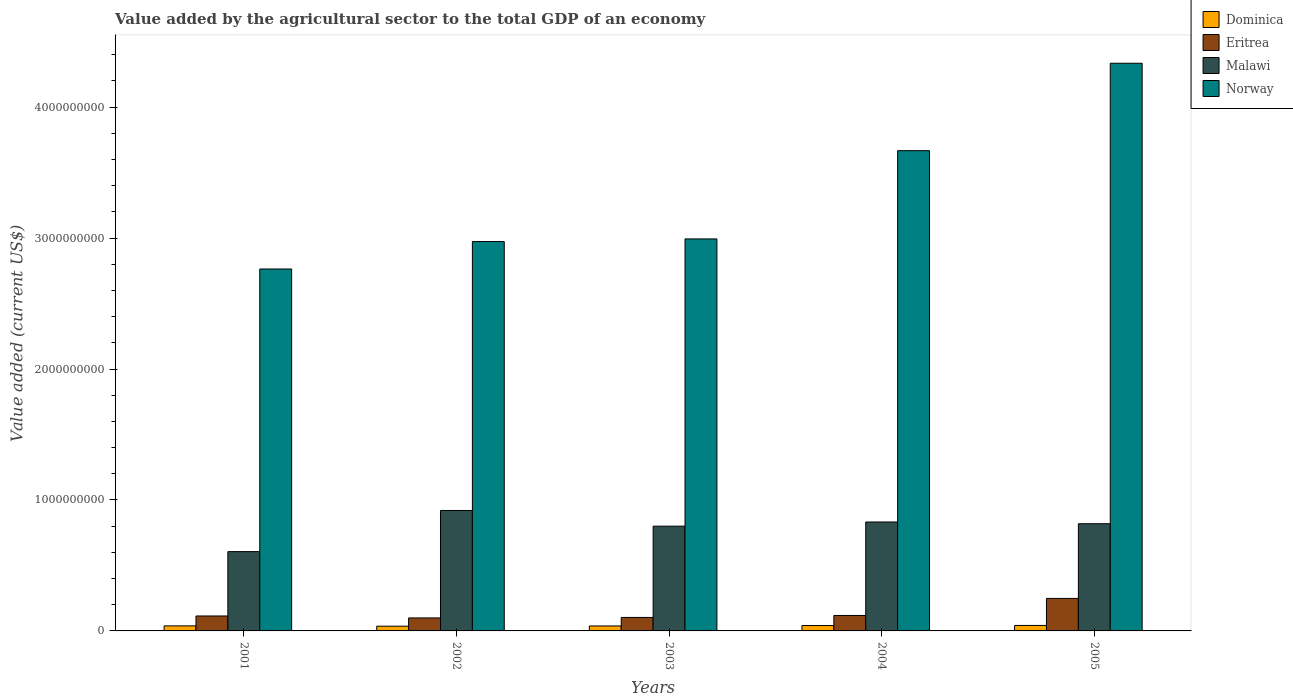How many groups of bars are there?
Provide a succinct answer. 5. Are the number of bars per tick equal to the number of legend labels?
Make the answer very short. Yes. How many bars are there on the 1st tick from the right?
Ensure brevity in your answer.  4. In how many cases, is the number of bars for a given year not equal to the number of legend labels?
Your answer should be compact. 0. What is the value added by the agricultural sector to the total GDP in Malawi in 2001?
Offer a very short reply. 6.06e+08. Across all years, what is the maximum value added by the agricultural sector to the total GDP in Dominica?
Your answer should be very brief. 4.19e+07. Across all years, what is the minimum value added by the agricultural sector to the total GDP in Dominica?
Provide a succinct answer. 3.61e+07. In which year was the value added by the agricultural sector to the total GDP in Eritrea maximum?
Your response must be concise. 2005. What is the total value added by the agricultural sector to the total GDP in Malawi in the graph?
Keep it short and to the point. 3.98e+09. What is the difference between the value added by the agricultural sector to the total GDP in Norway in 2001 and that in 2005?
Offer a very short reply. -1.57e+09. What is the difference between the value added by the agricultural sector to the total GDP in Norway in 2003 and the value added by the agricultural sector to the total GDP in Eritrea in 2004?
Provide a succinct answer. 2.88e+09. What is the average value added by the agricultural sector to the total GDP in Malawi per year?
Your answer should be compact. 7.95e+08. In the year 2005, what is the difference between the value added by the agricultural sector to the total GDP in Dominica and value added by the agricultural sector to the total GDP in Norway?
Offer a terse response. -4.29e+09. What is the ratio of the value added by the agricultural sector to the total GDP in Malawi in 2002 to that in 2005?
Give a very brief answer. 1.12. Is the value added by the agricultural sector to the total GDP in Malawi in 2001 less than that in 2005?
Give a very brief answer. Yes. Is the difference between the value added by the agricultural sector to the total GDP in Dominica in 2002 and 2004 greater than the difference between the value added by the agricultural sector to the total GDP in Norway in 2002 and 2004?
Provide a succinct answer. Yes. What is the difference between the highest and the second highest value added by the agricultural sector to the total GDP in Norway?
Provide a succinct answer. 6.68e+08. What is the difference between the highest and the lowest value added by the agricultural sector to the total GDP in Eritrea?
Ensure brevity in your answer.  1.49e+08. In how many years, is the value added by the agricultural sector to the total GDP in Dominica greater than the average value added by the agricultural sector to the total GDP in Dominica taken over all years?
Provide a short and direct response. 2. Is it the case that in every year, the sum of the value added by the agricultural sector to the total GDP in Dominica and value added by the agricultural sector to the total GDP in Malawi is greater than the sum of value added by the agricultural sector to the total GDP in Eritrea and value added by the agricultural sector to the total GDP in Norway?
Your answer should be very brief. No. What does the 1st bar from the left in 2003 represents?
Ensure brevity in your answer.  Dominica. What does the 3rd bar from the right in 2003 represents?
Ensure brevity in your answer.  Eritrea. Are all the bars in the graph horizontal?
Make the answer very short. No. How many years are there in the graph?
Ensure brevity in your answer.  5. Are the values on the major ticks of Y-axis written in scientific E-notation?
Your answer should be very brief. No. Does the graph contain any zero values?
Give a very brief answer. No. Does the graph contain grids?
Provide a short and direct response. No. How are the legend labels stacked?
Make the answer very short. Vertical. What is the title of the graph?
Your response must be concise. Value added by the agricultural sector to the total GDP of an economy. What is the label or title of the X-axis?
Provide a succinct answer. Years. What is the label or title of the Y-axis?
Make the answer very short. Value added (current US$). What is the Value added (current US$) of Dominica in 2001?
Keep it short and to the point. 3.84e+07. What is the Value added (current US$) in Eritrea in 2001?
Give a very brief answer. 1.14e+08. What is the Value added (current US$) of Malawi in 2001?
Your answer should be very brief. 6.06e+08. What is the Value added (current US$) in Norway in 2001?
Ensure brevity in your answer.  2.76e+09. What is the Value added (current US$) of Dominica in 2002?
Provide a short and direct response. 3.61e+07. What is the Value added (current US$) in Eritrea in 2002?
Offer a very short reply. 9.92e+07. What is the Value added (current US$) of Malawi in 2002?
Give a very brief answer. 9.20e+08. What is the Value added (current US$) of Norway in 2002?
Your answer should be very brief. 2.97e+09. What is the Value added (current US$) in Dominica in 2003?
Make the answer very short. 3.79e+07. What is the Value added (current US$) in Eritrea in 2003?
Give a very brief answer. 1.03e+08. What is the Value added (current US$) in Malawi in 2003?
Ensure brevity in your answer.  8.00e+08. What is the Value added (current US$) of Norway in 2003?
Make the answer very short. 2.99e+09. What is the Value added (current US$) in Dominica in 2004?
Make the answer very short. 4.11e+07. What is the Value added (current US$) of Eritrea in 2004?
Offer a terse response. 1.18e+08. What is the Value added (current US$) in Malawi in 2004?
Give a very brief answer. 8.32e+08. What is the Value added (current US$) in Norway in 2004?
Your answer should be compact. 3.67e+09. What is the Value added (current US$) in Dominica in 2005?
Provide a succinct answer. 4.19e+07. What is the Value added (current US$) in Eritrea in 2005?
Offer a very short reply. 2.48e+08. What is the Value added (current US$) of Malawi in 2005?
Make the answer very short. 8.19e+08. What is the Value added (current US$) in Norway in 2005?
Give a very brief answer. 4.33e+09. Across all years, what is the maximum Value added (current US$) of Dominica?
Your answer should be compact. 4.19e+07. Across all years, what is the maximum Value added (current US$) in Eritrea?
Keep it short and to the point. 2.48e+08. Across all years, what is the maximum Value added (current US$) of Malawi?
Offer a very short reply. 9.20e+08. Across all years, what is the maximum Value added (current US$) of Norway?
Ensure brevity in your answer.  4.33e+09. Across all years, what is the minimum Value added (current US$) of Dominica?
Ensure brevity in your answer.  3.61e+07. Across all years, what is the minimum Value added (current US$) in Eritrea?
Keep it short and to the point. 9.92e+07. Across all years, what is the minimum Value added (current US$) in Malawi?
Offer a very short reply. 6.06e+08. Across all years, what is the minimum Value added (current US$) in Norway?
Ensure brevity in your answer.  2.76e+09. What is the total Value added (current US$) of Dominica in the graph?
Your answer should be compact. 1.95e+08. What is the total Value added (current US$) of Eritrea in the graph?
Your answer should be very brief. 6.83e+08. What is the total Value added (current US$) of Malawi in the graph?
Ensure brevity in your answer.  3.98e+09. What is the total Value added (current US$) of Norway in the graph?
Your answer should be compact. 1.67e+1. What is the difference between the Value added (current US$) of Dominica in 2001 and that in 2002?
Offer a terse response. 2.31e+06. What is the difference between the Value added (current US$) of Eritrea in 2001 and that in 2002?
Give a very brief answer. 1.49e+07. What is the difference between the Value added (current US$) in Malawi in 2001 and that in 2002?
Provide a short and direct response. -3.14e+08. What is the difference between the Value added (current US$) of Norway in 2001 and that in 2002?
Provide a short and direct response. -2.10e+08. What is the difference between the Value added (current US$) of Dominica in 2001 and that in 2003?
Keep it short and to the point. 5.33e+05. What is the difference between the Value added (current US$) in Eritrea in 2001 and that in 2003?
Make the answer very short. 1.11e+07. What is the difference between the Value added (current US$) of Malawi in 2001 and that in 2003?
Your answer should be very brief. -1.94e+08. What is the difference between the Value added (current US$) in Norway in 2001 and that in 2003?
Provide a short and direct response. -2.30e+08. What is the difference between the Value added (current US$) of Dominica in 2001 and that in 2004?
Make the answer very short. -2.69e+06. What is the difference between the Value added (current US$) of Eritrea in 2001 and that in 2004?
Offer a terse response. -3.94e+06. What is the difference between the Value added (current US$) in Malawi in 2001 and that in 2004?
Keep it short and to the point. -2.26e+08. What is the difference between the Value added (current US$) of Norway in 2001 and that in 2004?
Make the answer very short. -9.03e+08. What is the difference between the Value added (current US$) in Dominica in 2001 and that in 2005?
Provide a short and direct response. -3.42e+06. What is the difference between the Value added (current US$) of Eritrea in 2001 and that in 2005?
Offer a terse response. -1.34e+08. What is the difference between the Value added (current US$) in Malawi in 2001 and that in 2005?
Give a very brief answer. -2.13e+08. What is the difference between the Value added (current US$) of Norway in 2001 and that in 2005?
Provide a short and direct response. -1.57e+09. What is the difference between the Value added (current US$) in Dominica in 2002 and that in 2003?
Your answer should be very brief. -1.78e+06. What is the difference between the Value added (current US$) of Eritrea in 2002 and that in 2003?
Your response must be concise. -3.75e+06. What is the difference between the Value added (current US$) in Malawi in 2002 and that in 2003?
Provide a short and direct response. 1.20e+08. What is the difference between the Value added (current US$) of Norway in 2002 and that in 2003?
Keep it short and to the point. -2.02e+07. What is the difference between the Value added (current US$) of Dominica in 2002 and that in 2004?
Provide a succinct answer. -5.00e+06. What is the difference between the Value added (current US$) in Eritrea in 2002 and that in 2004?
Offer a terse response. -1.88e+07. What is the difference between the Value added (current US$) in Malawi in 2002 and that in 2004?
Provide a short and direct response. 8.80e+07. What is the difference between the Value added (current US$) of Norway in 2002 and that in 2004?
Provide a succinct answer. -6.94e+08. What is the difference between the Value added (current US$) of Dominica in 2002 and that in 2005?
Your response must be concise. -5.73e+06. What is the difference between the Value added (current US$) in Eritrea in 2002 and that in 2005?
Your response must be concise. -1.49e+08. What is the difference between the Value added (current US$) of Malawi in 2002 and that in 2005?
Provide a short and direct response. 1.01e+08. What is the difference between the Value added (current US$) of Norway in 2002 and that in 2005?
Make the answer very short. -1.36e+09. What is the difference between the Value added (current US$) of Dominica in 2003 and that in 2004?
Keep it short and to the point. -3.22e+06. What is the difference between the Value added (current US$) in Eritrea in 2003 and that in 2004?
Your answer should be very brief. -1.51e+07. What is the difference between the Value added (current US$) in Malawi in 2003 and that in 2004?
Provide a short and direct response. -3.19e+07. What is the difference between the Value added (current US$) in Norway in 2003 and that in 2004?
Ensure brevity in your answer.  -6.74e+08. What is the difference between the Value added (current US$) in Dominica in 2003 and that in 2005?
Your response must be concise. -3.96e+06. What is the difference between the Value added (current US$) of Eritrea in 2003 and that in 2005?
Your answer should be very brief. -1.45e+08. What is the difference between the Value added (current US$) of Malawi in 2003 and that in 2005?
Your answer should be very brief. -1.87e+07. What is the difference between the Value added (current US$) in Norway in 2003 and that in 2005?
Give a very brief answer. -1.34e+09. What is the difference between the Value added (current US$) in Dominica in 2004 and that in 2005?
Make the answer very short. -7.34e+05. What is the difference between the Value added (current US$) of Eritrea in 2004 and that in 2005?
Offer a terse response. -1.30e+08. What is the difference between the Value added (current US$) in Malawi in 2004 and that in 2005?
Ensure brevity in your answer.  1.32e+07. What is the difference between the Value added (current US$) in Norway in 2004 and that in 2005?
Your answer should be very brief. -6.68e+08. What is the difference between the Value added (current US$) of Dominica in 2001 and the Value added (current US$) of Eritrea in 2002?
Your response must be concise. -6.08e+07. What is the difference between the Value added (current US$) of Dominica in 2001 and the Value added (current US$) of Malawi in 2002?
Provide a succinct answer. -8.81e+08. What is the difference between the Value added (current US$) of Dominica in 2001 and the Value added (current US$) of Norway in 2002?
Provide a short and direct response. -2.93e+09. What is the difference between the Value added (current US$) in Eritrea in 2001 and the Value added (current US$) in Malawi in 2002?
Your answer should be very brief. -8.06e+08. What is the difference between the Value added (current US$) of Eritrea in 2001 and the Value added (current US$) of Norway in 2002?
Your response must be concise. -2.86e+09. What is the difference between the Value added (current US$) of Malawi in 2001 and the Value added (current US$) of Norway in 2002?
Keep it short and to the point. -2.37e+09. What is the difference between the Value added (current US$) in Dominica in 2001 and the Value added (current US$) in Eritrea in 2003?
Ensure brevity in your answer.  -6.45e+07. What is the difference between the Value added (current US$) in Dominica in 2001 and the Value added (current US$) in Malawi in 2003?
Make the answer very short. -7.61e+08. What is the difference between the Value added (current US$) in Dominica in 2001 and the Value added (current US$) in Norway in 2003?
Keep it short and to the point. -2.96e+09. What is the difference between the Value added (current US$) of Eritrea in 2001 and the Value added (current US$) of Malawi in 2003?
Your answer should be very brief. -6.86e+08. What is the difference between the Value added (current US$) in Eritrea in 2001 and the Value added (current US$) in Norway in 2003?
Provide a succinct answer. -2.88e+09. What is the difference between the Value added (current US$) of Malawi in 2001 and the Value added (current US$) of Norway in 2003?
Offer a terse response. -2.39e+09. What is the difference between the Value added (current US$) in Dominica in 2001 and the Value added (current US$) in Eritrea in 2004?
Ensure brevity in your answer.  -7.96e+07. What is the difference between the Value added (current US$) in Dominica in 2001 and the Value added (current US$) in Malawi in 2004?
Your response must be concise. -7.93e+08. What is the difference between the Value added (current US$) of Dominica in 2001 and the Value added (current US$) of Norway in 2004?
Provide a succinct answer. -3.63e+09. What is the difference between the Value added (current US$) in Eritrea in 2001 and the Value added (current US$) in Malawi in 2004?
Keep it short and to the point. -7.18e+08. What is the difference between the Value added (current US$) in Eritrea in 2001 and the Value added (current US$) in Norway in 2004?
Keep it short and to the point. -3.55e+09. What is the difference between the Value added (current US$) of Malawi in 2001 and the Value added (current US$) of Norway in 2004?
Offer a very short reply. -3.06e+09. What is the difference between the Value added (current US$) in Dominica in 2001 and the Value added (current US$) in Eritrea in 2005?
Make the answer very short. -2.10e+08. What is the difference between the Value added (current US$) of Dominica in 2001 and the Value added (current US$) of Malawi in 2005?
Give a very brief answer. -7.80e+08. What is the difference between the Value added (current US$) of Dominica in 2001 and the Value added (current US$) of Norway in 2005?
Your answer should be very brief. -4.30e+09. What is the difference between the Value added (current US$) in Eritrea in 2001 and the Value added (current US$) in Malawi in 2005?
Offer a very short reply. -7.05e+08. What is the difference between the Value added (current US$) in Eritrea in 2001 and the Value added (current US$) in Norway in 2005?
Keep it short and to the point. -4.22e+09. What is the difference between the Value added (current US$) of Malawi in 2001 and the Value added (current US$) of Norway in 2005?
Offer a very short reply. -3.73e+09. What is the difference between the Value added (current US$) of Dominica in 2002 and the Value added (current US$) of Eritrea in 2003?
Give a very brief answer. -6.68e+07. What is the difference between the Value added (current US$) in Dominica in 2002 and the Value added (current US$) in Malawi in 2003?
Offer a very short reply. -7.64e+08. What is the difference between the Value added (current US$) of Dominica in 2002 and the Value added (current US$) of Norway in 2003?
Your answer should be compact. -2.96e+09. What is the difference between the Value added (current US$) of Eritrea in 2002 and the Value added (current US$) of Malawi in 2003?
Your answer should be compact. -7.01e+08. What is the difference between the Value added (current US$) in Eritrea in 2002 and the Value added (current US$) in Norway in 2003?
Give a very brief answer. -2.89e+09. What is the difference between the Value added (current US$) in Malawi in 2002 and the Value added (current US$) in Norway in 2003?
Your response must be concise. -2.07e+09. What is the difference between the Value added (current US$) of Dominica in 2002 and the Value added (current US$) of Eritrea in 2004?
Your answer should be compact. -8.19e+07. What is the difference between the Value added (current US$) of Dominica in 2002 and the Value added (current US$) of Malawi in 2004?
Your response must be concise. -7.96e+08. What is the difference between the Value added (current US$) of Dominica in 2002 and the Value added (current US$) of Norway in 2004?
Provide a succinct answer. -3.63e+09. What is the difference between the Value added (current US$) in Eritrea in 2002 and the Value added (current US$) in Malawi in 2004?
Offer a very short reply. -7.33e+08. What is the difference between the Value added (current US$) of Eritrea in 2002 and the Value added (current US$) of Norway in 2004?
Provide a succinct answer. -3.57e+09. What is the difference between the Value added (current US$) in Malawi in 2002 and the Value added (current US$) in Norway in 2004?
Ensure brevity in your answer.  -2.75e+09. What is the difference between the Value added (current US$) in Dominica in 2002 and the Value added (current US$) in Eritrea in 2005?
Provide a succinct answer. -2.12e+08. What is the difference between the Value added (current US$) of Dominica in 2002 and the Value added (current US$) of Malawi in 2005?
Offer a very short reply. -7.83e+08. What is the difference between the Value added (current US$) of Dominica in 2002 and the Value added (current US$) of Norway in 2005?
Your answer should be very brief. -4.30e+09. What is the difference between the Value added (current US$) of Eritrea in 2002 and the Value added (current US$) of Malawi in 2005?
Your answer should be very brief. -7.19e+08. What is the difference between the Value added (current US$) in Eritrea in 2002 and the Value added (current US$) in Norway in 2005?
Offer a terse response. -4.24e+09. What is the difference between the Value added (current US$) in Malawi in 2002 and the Value added (current US$) in Norway in 2005?
Give a very brief answer. -3.42e+09. What is the difference between the Value added (current US$) of Dominica in 2003 and the Value added (current US$) of Eritrea in 2004?
Ensure brevity in your answer.  -8.01e+07. What is the difference between the Value added (current US$) in Dominica in 2003 and the Value added (current US$) in Malawi in 2004?
Provide a short and direct response. -7.94e+08. What is the difference between the Value added (current US$) in Dominica in 2003 and the Value added (current US$) in Norway in 2004?
Your response must be concise. -3.63e+09. What is the difference between the Value added (current US$) of Eritrea in 2003 and the Value added (current US$) of Malawi in 2004?
Offer a very short reply. -7.29e+08. What is the difference between the Value added (current US$) in Eritrea in 2003 and the Value added (current US$) in Norway in 2004?
Offer a very short reply. -3.56e+09. What is the difference between the Value added (current US$) in Malawi in 2003 and the Value added (current US$) in Norway in 2004?
Provide a succinct answer. -2.87e+09. What is the difference between the Value added (current US$) of Dominica in 2003 and the Value added (current US$) of Eritrea in 2005?
Offer a terse response. -2.10e+08. What is the difference between the Value added (current US$) in Dominica in 2003 and the Value added (current US$) in Malawi in 2005?
Your answer should be compact. -7.81e+08. What is the difference between the Value added (current US$) in Dominica in 2003 and the Value added (current US$) in Norway in 2005?
Give a very brief answer. -4.30e+09. What is the difference between the Value added (current US$) of Eritrea in 2003 and the Value added (current US$) of Malawi in 2005?
Your answer should be compact. -7.16e+08. What is the difference between the Value added (current US$) of Eritrea in 2003 and the Value added (current US$) of Norway in 2005?
Your answer should be compact. -4.23e+09. What is the difference between the Value added (current US$) in Malawi in 2003 and the Value added (current US$) in Norway in 2005?
Your response must be concise. -3.54e+09. What is the difference between the Value added (current US$) in Dominica in 2004 and the Value added (current US$) in Eritrea in 2005?
Ensure brevity in your answer.  -2.07e+08. What is the difference between the Value added (current US$) in Dominica in 2004 and the Value added (current US$) in Malawi in 2005?
Give a very brief answer. -7.78e+08. What is the difference between the Value added (current US$) in Dominica in 2004 and the Value added (current US$) in Norway in 2005?
Give a very brief answer. -4.29e+09. What is the difference between the Value added (current US$) of Eritrea in 2004 and the Value added (current US$) of Malawi in 2005?
Make the answer very short. -7.01e+08. What is the difference between the Value added (current US$) in Eritrea in 2004 and the Value added (current US$) in Norway in 2005?
Offer a very short reply. -4.22e+09. What is the difference between the Value added (current US$) in Malawi in 2004 and the Value added (current US$) in Norway in 2005?
Provide a short and direct response. -3.50e+09. What is the average Value added (current US$) in Dominica per year?
Provide a succinct answer. 3.91e+07. What is the average Value added (current US$) in Eritrea per year?
Make the answer very short. 1.37e+08. What is the average Value added (current US$) of Malawi per year?
Offer a terse response. 7.95e+08. What is the average Value added (current US$) in Norway per year?
Provide a succinct answer. 3.35e+09. In the year 2001, what is the difference between the Value added (current US$) in Dominica and Value added (current US$) in Eritrea?
Give a very brief answer. -7.57e+07. In the year 2001, what is the difference between the Value added (current US$) of Dominica and Value added (current US$) of Malawi?
Make the answer very short. -5.67e+08. In the year 2001, what is the difference between the Value added (current US$) in Dominica and Value added (current US$) in Norway?
Offer a terse response. -2.73e+09. In the year 2001, what is the difference between the Value added (current US$) in Eritrea and Value added (current US$) in Malawi?
Your answer should be very brief. -4.92e+08. In the year 2001, what is the difference between the Value added (current US$) of Eritrea and Value added (current US$) of Norway?
Your answer should be compact. -2.65e+09. In the year 2001, what is the difference between the Value added (current US$) of Malawi and Value added (current US$) of Norway?
Your response must be concise. -2.16e+09. In the year 2002, what is the difference between the Value added (current US$) of Dominica and Value added (current US$) of Eritrea?
Ensure brevity in your answer.  -6.31e+07. In the year 2002, what is the difference between the Value added (current US$) of Dominica and Value added (current US$) of Malawi?
Your response must be concise. -8.84e+08. In the year 2002, what is the difference between the Value added (current US$) of Dominica and Value added (current US$) of Norway?
Your answer should be very brief. -2.94e+09. In the year 2002, what is the difference between the Value added (current US$) in Eritrea and Value added (current US$) in Malawi?
Ensure brevity in your answer.  -8.21e+08. In the year 2002, what is the difference between the Value added (current US$) of Eritrea and Value added (current US$) of Norway?
Provide a short and direct response. -2.87e+09. In the year 2002, what is the difference between the Value added (current US$) in Malawi and Value added (current US$) in Norway?
Your response must be concise. -2.05e+09. In the year 2003, what is the difference between the Value added (current US$) of Dominica and Value added (current US$) of Eritrea?
Your response must be concise. -6.51e+07. In the year 2003, what is the difference between the Value added (current US$) in Dominica and Value added (current US$) in Malawi?
Offer a terse response. -7.62e+08. In the year 2003, what is the difference between the Value added (current US$) in Dominica and Value added (current US$) in Norway?
Offer a terse response. -2.96e+09. In the year 2003, what is the difference between the Value added (current US$) of Eritrea and Value added (current US$) of Malawi?
Offer a terse response. -6.97e+08. In the year 2003, what is the difference between the Value added (current US$) in Eritrea and Value added (current US$) in Norway?
Your answer should be compact. -2.89e+09. In the year 2003, what is the difference between the Value added (current US$) of Malawi and Value added (current US$) of Norway?
Your response must be concise. -2.19e+09. In the year 2004, what is the difference between the Value added (current US$) of Dominica and Value added (current US$) of Eritrea?
Give a very brief answer. -7.69e+07. In the year 2004, what is the difference between the Value added (current US$) of Dominica and Value added (current US$) of Malawi?
Offer a terse response. -7.91e+08. In the year 2004, what is the difference between the Value added (current US$) in Dominica and Value added (current US$) in Norway?
Make the answer very short. -3.63e+09. In the year 2004, what is the difference between the Value added (current US$) of Eritrea and Value added (current US$) of Malawi?
Your answer should be compact. -7.14e+08. In the year 2004, what is the difference between the Value added (current US$) in Eritrea and Value added (current US$) in Norway?
Provide a short and direct response. -3.55e+09. In the year 2004, what is the difference between the Value added (current US$) in Malawi and Value added (current US$) in Norway?
Keep it short and to the point. -2.84e+09. In the year 2005, what is the difference between the Value added (current US$) in Dominica and Value added (current US$) in Eritrea?
Provide a short and direct response. -2.06e+08. In the year 2005, what is the difference between the Value added (current US$) in Dominica and Value added (current US$) in Malawi?
Your answer should be compact. -7.77e+08. In the year 2005, what is the difference between the Value added (current US$) of Dominica and Value added (current US$) of Norway?
Ensure brevity in your answer.  -4.29e+09. In the year 2005, what is the difference between the Value added (current US$) in Eritrea and Value added (current US$) in Malawi?
Give a very brief answer. -5.70e+08. In the year 2005, what is the difference between the Value added (current US$) of Eritrea and Value added (current US$) of Norway?
Provide a short and direct response. -4.09e+09. In the year 2005, what is the difference between the Value added (current US$) in Malawi and Value added (current US$) in Norway?
Provide a short and direct response. -3.52e+09. What is the ratio of the Value added (current US$) of Dominica in 2001 to that in 2002?
Your response must be concise. 1.06. What is the ratio of the Value added (current US$) of Eritrea in 2001 to that in 2002?
Offer a terse response. 1.15. What is the ratio of the Value added (current US$) in Malawi in 2001 to that in 2002?
Provide a succinct answer. 0.66. What is the ratio of the Value added (current US$) in Norway in 2001 to that in 2002?
Your answer should be compact. 0.93. What is the ratio of the Value added (current US$) in Dominica in 2001 to that in 2003?
Give a very brief answer. 1.01. What is the ratio of the Value added (current US$) in Eritrea in 2001 to that in 2003?
Provide a succinct answer. 1.11. What is the ratio of the Value added (current US$) in Malawi in 2001 to that in 2003?
Your answer should be compact. 0.76. What is the ratio of the Value added (current US$) in Norway in 2001 to that in 2003?
Your response must be concise. 0.92. What is the ratio of the Value added (current US$) of Dominica in 2001 to that in 2004?
Your answer should be very brief. 0.93. What is the ratio of the Value added (current US$) of Eritrea in 2001 to that in 2004?
Ensure brevity in your answer.  0.97. What is the ratio of the Value added (current US$) in Malawi in 2001 to that in 2004?
Provide a short and direct response. 0.73. What is the ratio of the Value added (current US$) in Norway in 2001 to that in 2004?
Your response must be concise. 0.75. What is the ratio of the Value added (current US$) of Dominica in 2001 to that in 2005?
Your answer should be very brief. 0.92. What is the ratio of the Value added (current US$) of Eritrea in 2001 to that in 2005?
Provide a succinct answer. 0.46. What is the ratio of the Value added (current US$) of Malawi in 2001 to that in 2005?
Provide a short and direct response. 0.74. What is the ratio of the Value added (current US$) of Norway in 2001 to that in 2005?
Offer a terse response. 0.64. What is the ratio of the Value added (current US$) of Dominica in 2002 to that in 2003?
Offer a terse response. 0.95. What is the ratio of the Value added (current US$) in Eritrea in 2002 to that in 2003?
Provide a short and direct response. 0.96. What is the ratio of the Value added (current US$) of Malawi in 2002 to that in 2003?
Give a very brief answer. 1.15. What is the ratio of the Value added (current US$) of Norway in 2002 to that in 2003?
Give a very brief answer. 0.99. What is the ratio of the Value added (current US$) in Dominica in 2002 to that in 2004?
Offer a very short reply. 0.88. What is the ratio of the Value added (current US$) in Eritrea in 2002 to that in 2004?
Make the answer very short. 0.84. What is the ratio of the Value added (current US$) in Malawi in 2002 to that in 2004?
Your answer should be very brief. 1.11. What is the ratio of the Value added (current US$) in Norway in 2002 to that in 2004?
Your answer should be very brief. 0.81. What is the ratio of the Value added (current US$) of Dominica in 2002 to that in 2005?
Your response must be concise. 0.86. What is the ratio of the Value added (current US$) of Eritrea in 2002 to that in 2005?
Your response must be concise. 0.4. What is the ratio of the Value added (current US$) of Malawi in 2002 to that in 2005?
Keep it short and to the point. 1.12. What is the ratio of the Value added (current US$) in Norway in 2002 to that in 2005?
Make the answer very short. 0.69. What is the ratio of the Value added (current US$) in Dominica in 2003 to that in 2004?
Give a very brief answer. 0.92. What is the ratio of the Value added (current US$) in Eritrea in 2003 to that in 2004?
Make the answer very short. 0.87. What is the ratio of the Value added (current US$) of Malawi in 2003 to that in 2004?
Ensure brevity in your answer.  0.96. What is the ratio of the Value added (current US$) in Norway in 2003 to that in 2004?
Keep it short and to the point. 0.82. What is the ratio of the Value added (current US$) in Dominica in 2003 to that in 2005?
Offer a very short reply. 0.91. What is the ratio of the Value added (current US$) of Eritrea in 2003 to that in 2005?
Offer a terse response. 0.41. What is the ratio of the Value added (current US$) in Malawi in 2003 to that in 2005?
Keep it short and to the point. 0.98. What is the ratio of the Value added (current US$) of Norway in 2003 to that in 2005?
Give a very brief answer. 0.69. What is the ratio of the Value added (current US$) of Dominica in 2004 to that in 2005?
Your answer should be very brief. 0.98. What is the ratio of the Value added (current US$) in Eritrea in 2004 to that in 2005?
Keep it short and to the point. 0.48. What is the ratio of the Value added (current US$) in Malawi in 2004 to that in 2005?
Ensure brevity in your answer.  1.02. What is the ratio of the Value added (current US$) in Norway in 2004 to that in 2005?
Your answer should be compact. 0.85. What is the difference between the highest and the second highest Value added (current US$) of Dominica?
Your answer should be very brief. 7.34e+05. What is the difference between the highest and the second highest Value added (current US$) in Eritrea?
Offer a very short reply. 1.30e+08. What is the difference between the highest and the second highest Value added (current US$) of Malawi?
Your response must be concise. 8.80e+07. What is the difference between the highest and the second highest Value added (current US$) in Norway?
Keep it short and to the point. 6.68e+08. What is the difference between the highest and the lowest Value added (current US$) of Dominica?
Your response must be concise. 5.73e+06. What is the difference between the highest and the lowest Value added (current US$) in Eritrea?
Provide a short and direct response. 1.49e+08. What is the difference between the highest and the lowest Value added (current US$) of Malawi?
Your answer should be compact. 3.14e+08. What is the difference between the highest and the lowest Value added (current US$) in Norway?
Provide a short and direct response. 1.57e+09. 